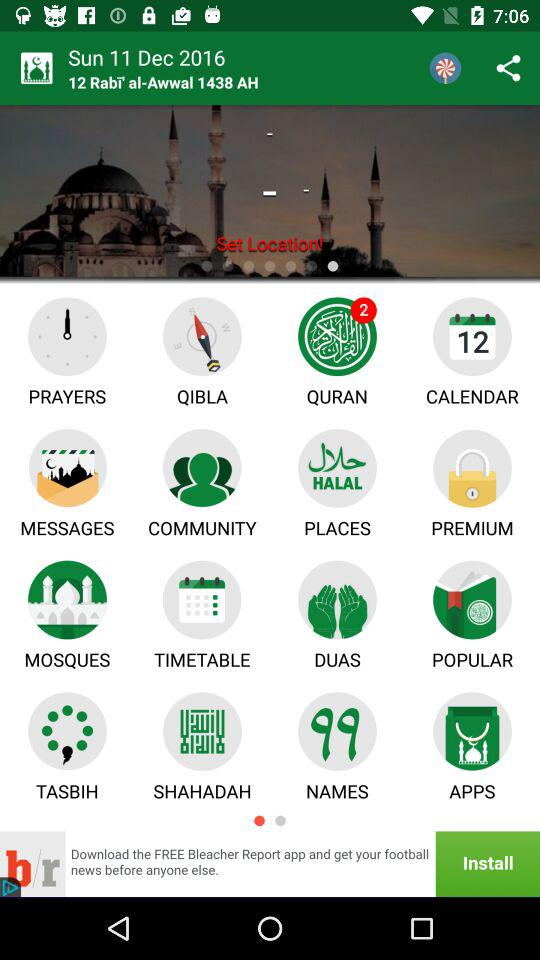What is the date? The date is Sunday, December 11, 2016. 